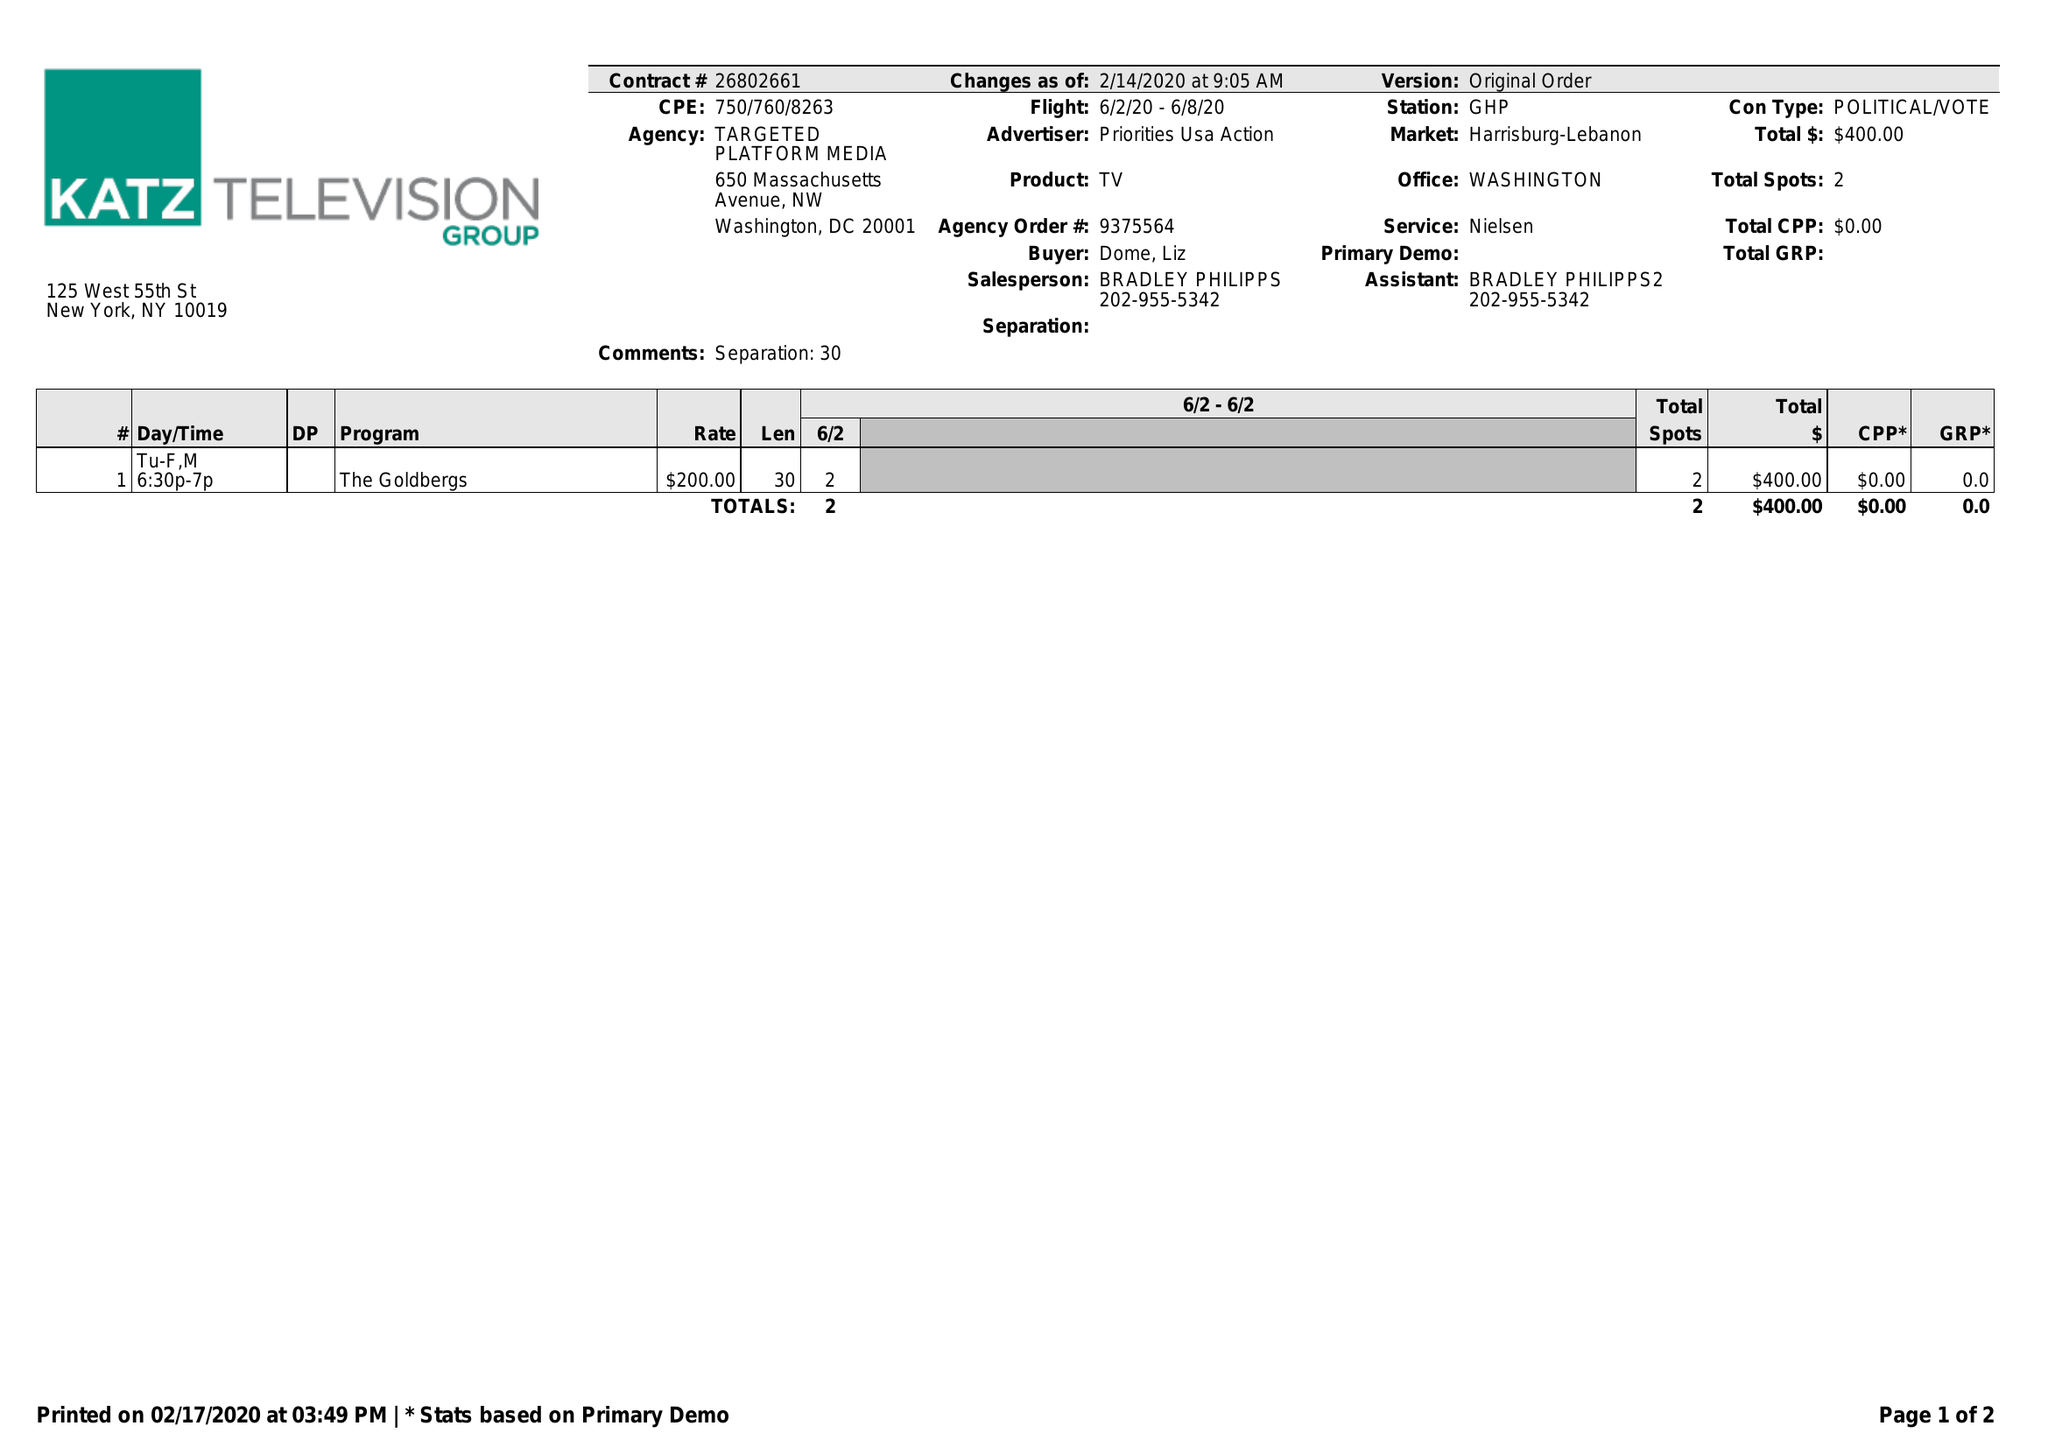What is the value for the contract_num?
Answer the question using a single word or phrase. 26802661 